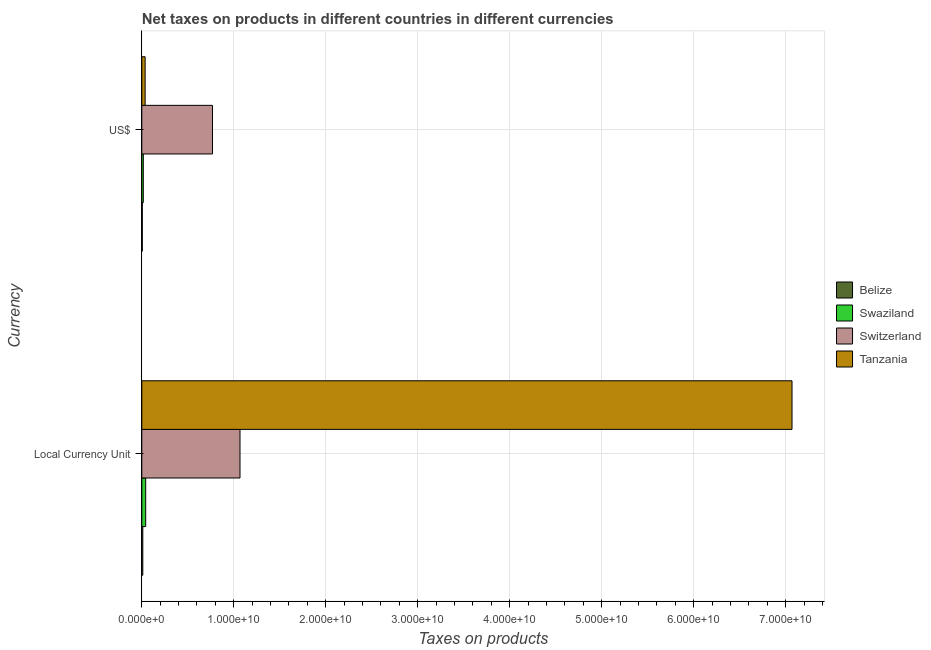How many groups of bars are there?
Offer a very short reply. 2. How many bars are there on the 2nd tick from the top?
Make the answer very short. 4. What is the label of the 1st group of bars from the top?
Make the answer very short. US$. What is the net taxes in us$ in Belize?
Keep it short and to the point. 5.40e+07. Across all countries, what is the maximum net taxes in us$?
Provide a succinct answer. 7.68e+09. Across all countries, what is the minimum net taxes in constant 2005 us$?
Offer a terse response. 1.08e+08. In which country was the net taxes in constant 2005 us$ maximum?
Your answer should be compact. Tanzania. In which country was the net taxes in us$ minimum?
Offer a terse response. Belize. What is the total net taxes in us$ in the graph?
Ensure brevity in your answer.  8.26e+09. What is the difference between the net taxes in constant 2005 us$ in Belize and that in Switzerland?
Your response must be concise. -1.06e+1. What is the difference between the net taxes in us$ in Tanzania and the net taxes in constant 2005 us$ in Belize?
Ensure brevity in your answer.  2.54e+08. What is the average net taxes in constant 2005 us$ per country?
Give a very brief answer. 2.05e+1. What is the difference between the net taxes in constant 2005 us$ and net taxes in us$ in Tanzania?
Provide a short and direct response. 7.03e+1. In how many countries, is the net taxes in constant 2005 us$ greater than 54000000000 units?
Offer a very short reply. 1. What is the ratio of the net taxes in constant 2005 us$ in Belize to that in Swaziland?
Keep it short and to the point. 0.26. What does the 2nd bar from the top in US$ represents?
Your response must be concise. Switzerland. What does the 3rd bar from the bottom in US$ represents?
Your response must be concise. Switzerland. How many bars are there?
Provide a short and direct response. 8. Are all the bars in the graph horizontal?
Provide a succinct answer. Yes. What is the difference between two consecutive major ticks on the X-axis?
Ensure brevity in your answer.  1.00e+1. Are the values on the major ticks of X-axis written in scientific E-notation?
Offer a very short reply. Yes. Where does the legend appear in the graph?
Your response must be concise. Center right. How are the legend labels stacked?
Provide a succinct answer. Vertical. What is the title of the graph?
Provide a short and direct response. Net taxes on products in different countries in different currencies. What is the label or title of the X-axis?
Your response must be concise. Taxes on products. What is the label or title of the Y-axis?
Offer a very short reply. Currency. What is the Taxes on products of Belize in Local Currency Unit?
Your response must be concise. 1.08e+08. What is the Taxes on products of Swaziland in Local Currency Unit?
Make the answer very short. 4.23e+08. What is the Taxes on products of Switzerland in Local Currency Unit?
Provide a short and direct response. 1.07e+1. What is the Taxes on products in Tanzania in Local Currency Unit?
Offer a terse response. 7.07e+1. What is the Taxes on products in Belize in US$?
Ensure brevity in your answer.  5.40e+07. What is the Taxes on products in Swaziland in US$?
Ensure brevity in your answer.  1.63e+08. What is the Taxes on products of Switzerland in US$?
Make the answer very short. 7.68e+09. What is the Taxes on products in Tanzania in US$?
Give a very brief answer. 3.62e+08. Across all Currency, what is the maximum Taxes on products of Belize?
Ensure brevity in your answer.  1.08e+08. Across all Currency, what is the maximum Taxes on products of Swaziland?
Give a very brief answer. 4.23e+08. Across all Currency, what is the maximum Taxes on products in Switzerland?
Offer a very short reply. 1.07e+1. Across all Currency, what is the maximum Taxes on products of Tanzania?
Provide a short and direct response. 7.07e+1. Across all Currency, what is the minimum Taxes on products of Belize?
Provide a short and direct response. 5.40e+07. Across all Currency, what is the minimum Taxes on products of Swaziland?
Provide a succinct answer. 1.63e+08. Across all Currency, what is the minimum Taxes on products in Switzerland?
Your answer should be very brief. 7.68e+09. Across all Currency, what is the minimum Taxes on products of Tanzania?
Your answer should be very brief. 3.62e+08. What is the total Taxes on products in Belize in the graph?
Ensure brevity in your answer.  1.62e+08. What is the total Taxes on products in Swaziland in the graph?
Provide a succinct answer. 5.86e+08. What is the total Taxes on products in Switzerland in the graph?
Your response must be concise. 1.84e+1. What is the total Taxes on products of Tanzania in the graph?
Offer a very short reply. 7.10e+1. What is the difference between the Taxes on products in Belize in Local Currency Unit and that in US$?
Give a very brief answer. 5.40e+07. What is the difference between the Taxes on products of Swaziland in Local Currency Unit and that in US$?
Offer a very short reply. 2.59e+08. What is the difference between the Taxes on products in Switzerland in Local Currency Unit and that in US$?
Your answer should be compact. 2.99e+09. What is the difference between the Taxes on products of Tanzania in Local Currency Unit and that in US$?
Give a very brief answer. 7.03e+1. What is the difference between the Taxes on products of Belize in Local Currency Unit and the Taxes on products of Swaziland in US$?
Provide a short and direct response. -5.55e+07. What is the difference between the Taxes on products in Belize in Local Currency Unit and the Taxes on products in Switzerland in US$?
Your answer should be compact. -7.58e+09. What is the difference between the Taxes on products in Belize in Local Currency Unit and the Taxes on products in Tanzania in US$?
Your response must be concise. -2.54e+08. What is the difference between the Taxes on products in Swaziland in Local Currency Unit and the Taxes on products in Switzerland in US$?
Ensure brevity in your answer.  -7.26e+09. What is the difference between the Taxes on products in Swaziland in Local Currency Unit and the Taxes on products in Tanzania in US$?
Your answer should be very brief. 6.03e+07. What is the difference between the Taxes on products of Switzerland in Local Currency Unit and the Taxes on products of Tanzania in US$?
Provide a short and direct response. 1.03e+1. What is the average Taxes on products in Belize per Currency?
Provide a succinct answer. 8.09e+07. What is the average Taxes on products in Swaziland per Currency?
Give a very brief answer. 2.93e+08. What is the average Taxes on products in Switzerland per Currency?
Offer a terse response. 9.18e+09. What is the average Taxes on products of Tanzania per Currency?
Make the answer very short. 3.55e+1. What is the difference between the Taxes on products of Belize and Taxes on products of Swaziland in Local Currency Unit?
Provide a short and direct response. -3.15e+08. What is the difference between the Taxes on products in Belize and Taxes on products in Switzerland in Local Currency Unit?
Offer a very short reply. -1.06e+1. What is the difference between the Taxes on products of Belize and Taxes on products of Tanzania in Local Currency Unit?
Give a very brief answer. -7.06e+1. What is the difference between the Taxes on products of Swaziland and Taxes on products of Switzerland in Local Currency Unit?
Ensure brevity in your answer.  -1.03e+1. What is the difference between the Taxes on products in Swaziland and Taxes on products in Tanzania in Local Currency Unit?
Make the answer very short. -7.03e+1. What is the difference between the Taxes on products in Switzerland and Taxes on products in Tanzania in Local Currency Unit?
Make the answer very short. -6.00e+1. What is the difference between the Taxes on products of Belize and Taxes on products of Swaziland in US$?
Your answer should be very brief. -1.09e+08. What is the difference between the Taxes on products of Belize and Taxes on products of Switzerland in US$?
Give a very brief answer. -7.63e+09. What is the difference between the Taxes on products of Belize and Taxes on products of Tanzania in US$?
Make the answer very short. -3.08e+08. What is the difference between the Taxes on products in Swaziland and Taxes on products in Switzerland in US$?
Ensure brevity in your answer.  -7.52e+09. What is the difference between the Taxes on products of Swaziland and Taxes on products of Tanzania in US$?
Your response must be concise. -1.99e+08. What is the difference between the Taxes on products of Switzerland and Taxes on products of Tanzania in US$?
Your answer should be very brief. 7.32e+09. What is the ratio of the Taxes on products in Belize in Local Currency Unit to that in US$?
Give a very brief answer. 2. What is the ratio of the Taxes on products in Swaziland in Local Currency Unit to that in US$?
Offer a very short reply. 2.59. What is the ratio of the Taxes on products of Switzerland in Local Currency Unit to that in US$?
Offer a terse response. 1.39. What is the ratio of the Taxes on products of Tanzania in Local Currency Unit to that in US$?
Your response must be concise. 195.06. What is the difference between the highest and the second highest Taxes on products of Belize?
Offer a terse response. 5.40e+07. What is the difference between the highest and the second highest Taxes on products in Swaziland?
Ensure brevity in your answer.  2.59e+08. What is the difference between the highest and the second highest Taxes on products of Switzerland?
Your answer should be very brief. 2.99e+09. What is the difference between the highest and the second highest Taxes on products of Tanzania?
Offer a very short reply. 7.03e+1. What is the difference between the highest and the lowest Taxes on products in Belize?
Your response must be concise. 5.40e+07. What is the difference between the highest and the lowest Taxes on products of Swaziland?
Offer a terse response. 2.59e+08. What is the difference between the highest and the lowest Taxes on products of Switzerland?
Your answer should be compact. 2.99e+09. What is the difference between the highest and the lowest Taxes on products of Tanzania?
Make the answer very short. 7.03e+1. 